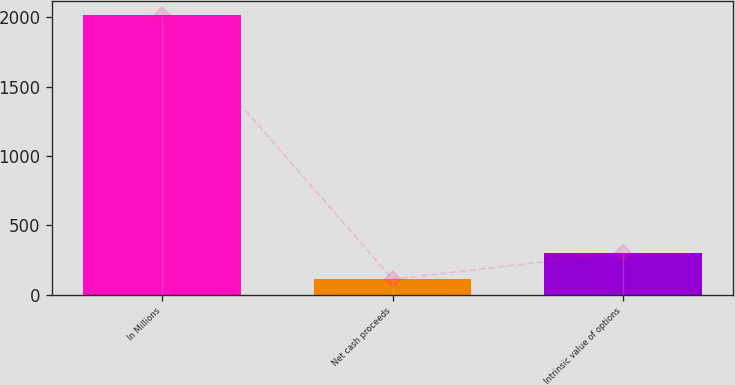Convert chart to OTSL. <chart><loc_0><loc_0><loc_500><loc_500><bar_chart><fcel>In Millions<fcel>Net cash proceeds<fcel>Intrinsic value of options<nl><fcel>2017<fcel>112.6<fcel>303.04<nl></chart> 